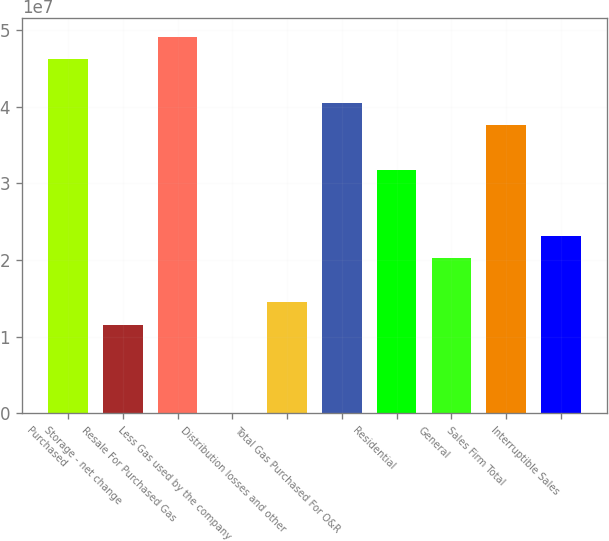<chart> <loc_0><loc_0><loc_500><loc_500><bar_chart><fcel>Purchased<fcel>Storage - net change<fcel>Resale For Purchased Gas<fcel>Less Gas used by the company<fcel>Distribution losses and other<fcel>Total Gas Purchased For O&R<fcel>Residential<fcel>General<fcel>Sales Firm Total<fcel>Interruptible Sales<nl><fcel>4.62343e+07<fcel>1.15868e+07<fcel>4.91216e+07<fcel>37630<fcel>1.44741e+07<fcel>4.04597e+07<fcel>3.17978e+07<fcel>2.02487e+07<fcel>3.75724e+07<fcel>2.31359e+07<nl></chart> 